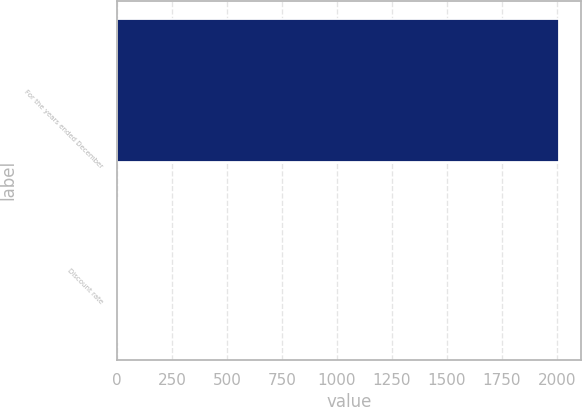Convert chart to OTSL. <chart><loc_0><loc_0><loc_500><loc_500><bar_chart><fcel>For the years ended December<fcel>Discount rate<nl><fcel>2010<fcel>5.7<nl></chart> 